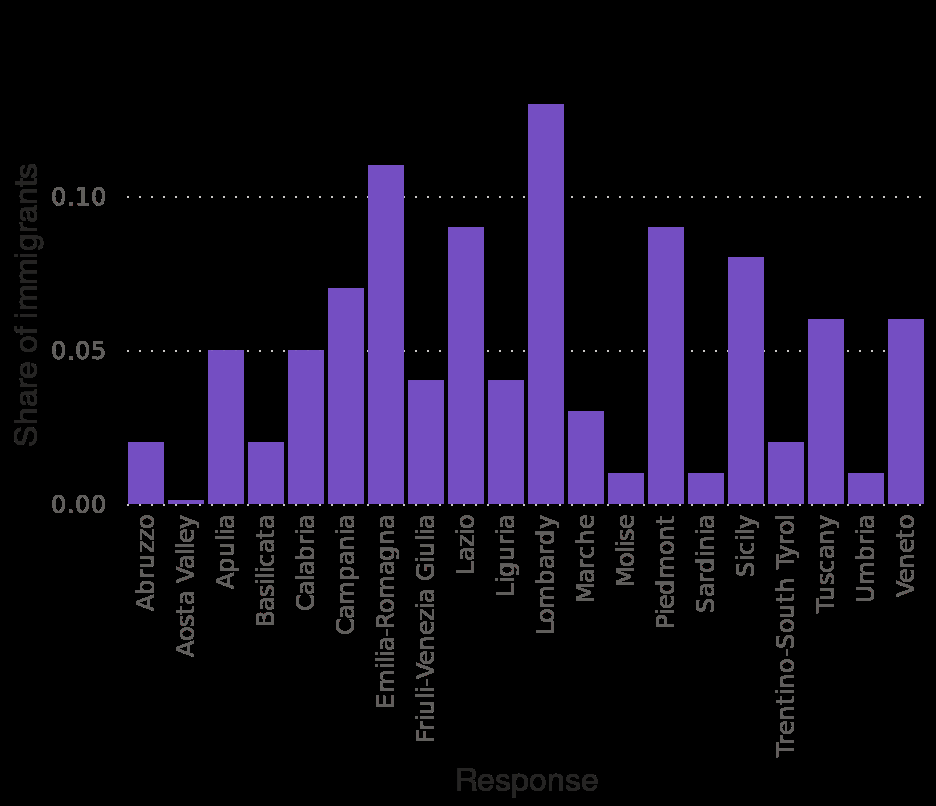<image>
What does the y-axis measure in the bar chart? The y-axis measures the share of immigrants with a linear scale ranging from 0.00 to 0.10. 